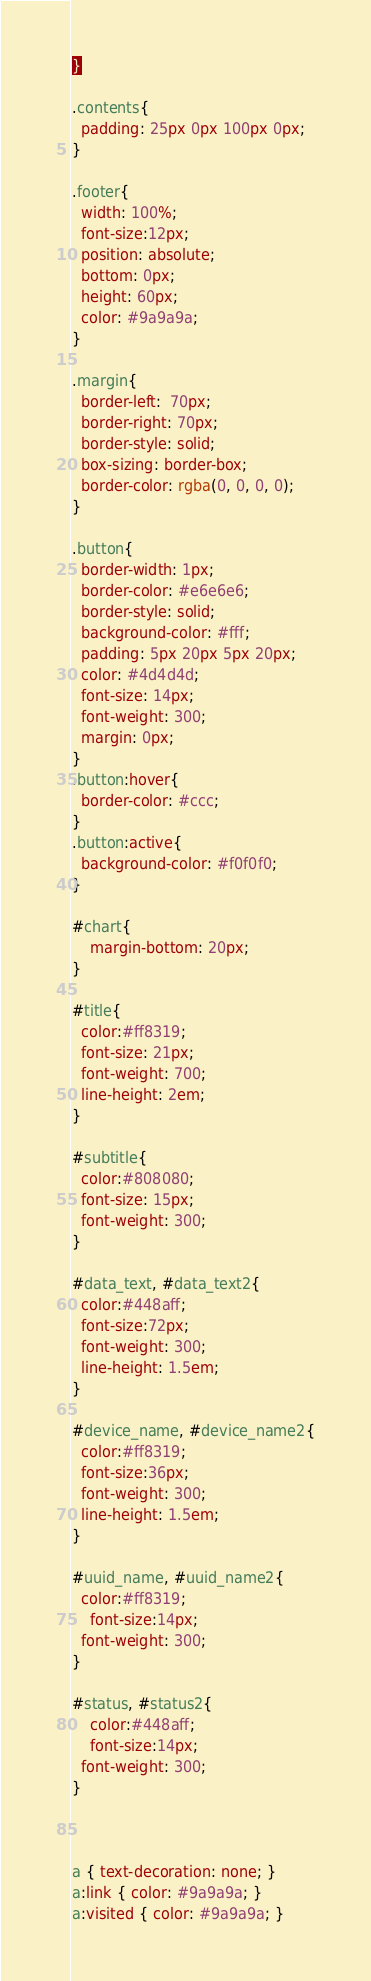<code> <loc_0><loc_0><loc_500><loc_500><_CSS_>}

.contents{
  padding: 25px 0px 100px 0px;
}

.footer{
  width: 100%;
  font-size:12px;
  position: absolute;
  bottom: 0px;
  height: 60px;
  color: #9a9a9a;
}

.margin{
  border-left:  70px;
  border-right: 70px;
  border-style: solid;
  box-sizing: border-box;
  border-color: rgba(0, 0, 0, 0);
}

.button{
  border-width: 1px;
  border-color: #e6e6e6;
  border-style: solid;
  background-color: #fff;
  padding: 5px 20px 5px 20px;
  color: #4d4d4d;
  font-size: 14px;
  font-weight: 300;
  margin: 0px;
}
.button:hover{
  border-color: #ccc;
}
.button:active{
  background-color: #f0f0f0;
}

#chart{
	margin-bottom: 20px;
}

#title{
  color:#ff8319;
  font-size: 21px;
  font-weight: 700;
  line-height: 2em;
}

#subtitle{
  color:#808080;
  font-size: 15px;
  font-weight: 300;
}

#data_text, #data_text2{
  color:#448aff;
  font-size:72px;
  font-weight: 300;
  line-height: 1.5em;
}

#device_name, #device_name2{
  color:#ff8319;
  font-size:36px;
  font-weight: 300;
  line-height: 1.5em;
}

#uuid_name, #uuid_name2{
  color:#ff8319;
	font-size:14px;
  font-weight: 300;
}

#status, #status2{
	color:#448aff;
	font-size:14px;
  font-weight: 300;
}



a { text-decoration: none; }
a:link { color: #9a9a9a; }
a:visited { color: #9a9a9a; }</code> 